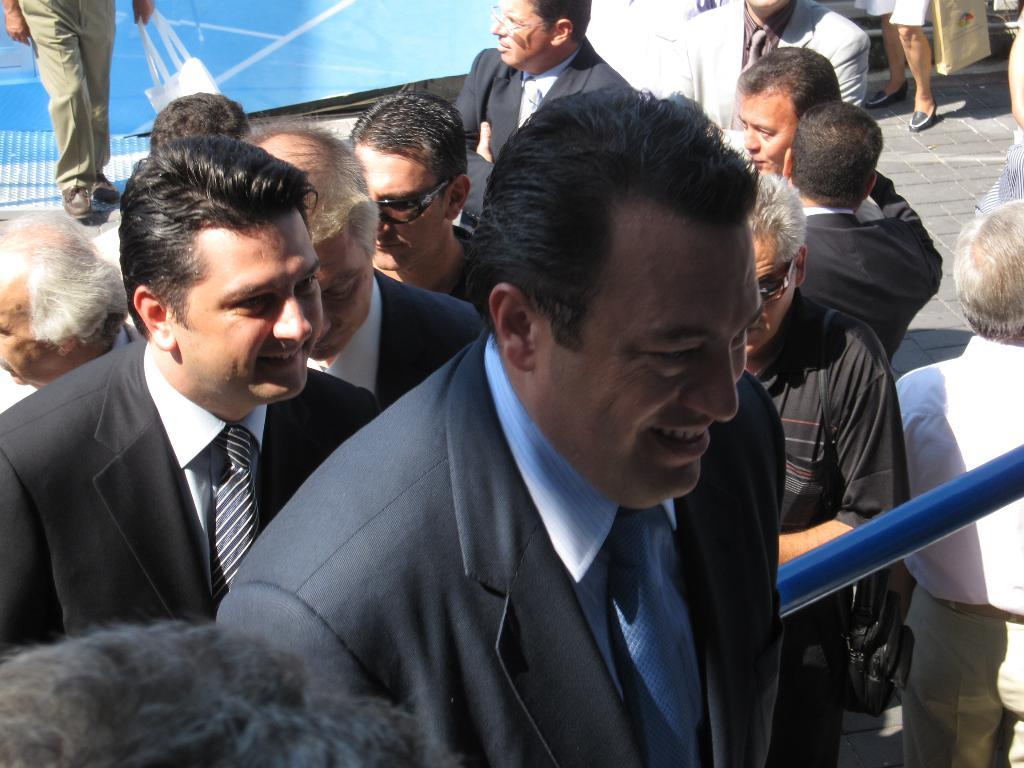What are the people in the image doing? There are people standing and walking in the image. Where are the people located in the image? The people are on a path and on stairs in the image. Can you tell me how many ducks are on the amusement ride in the image? There is no amusement ride or duck present in the image. 